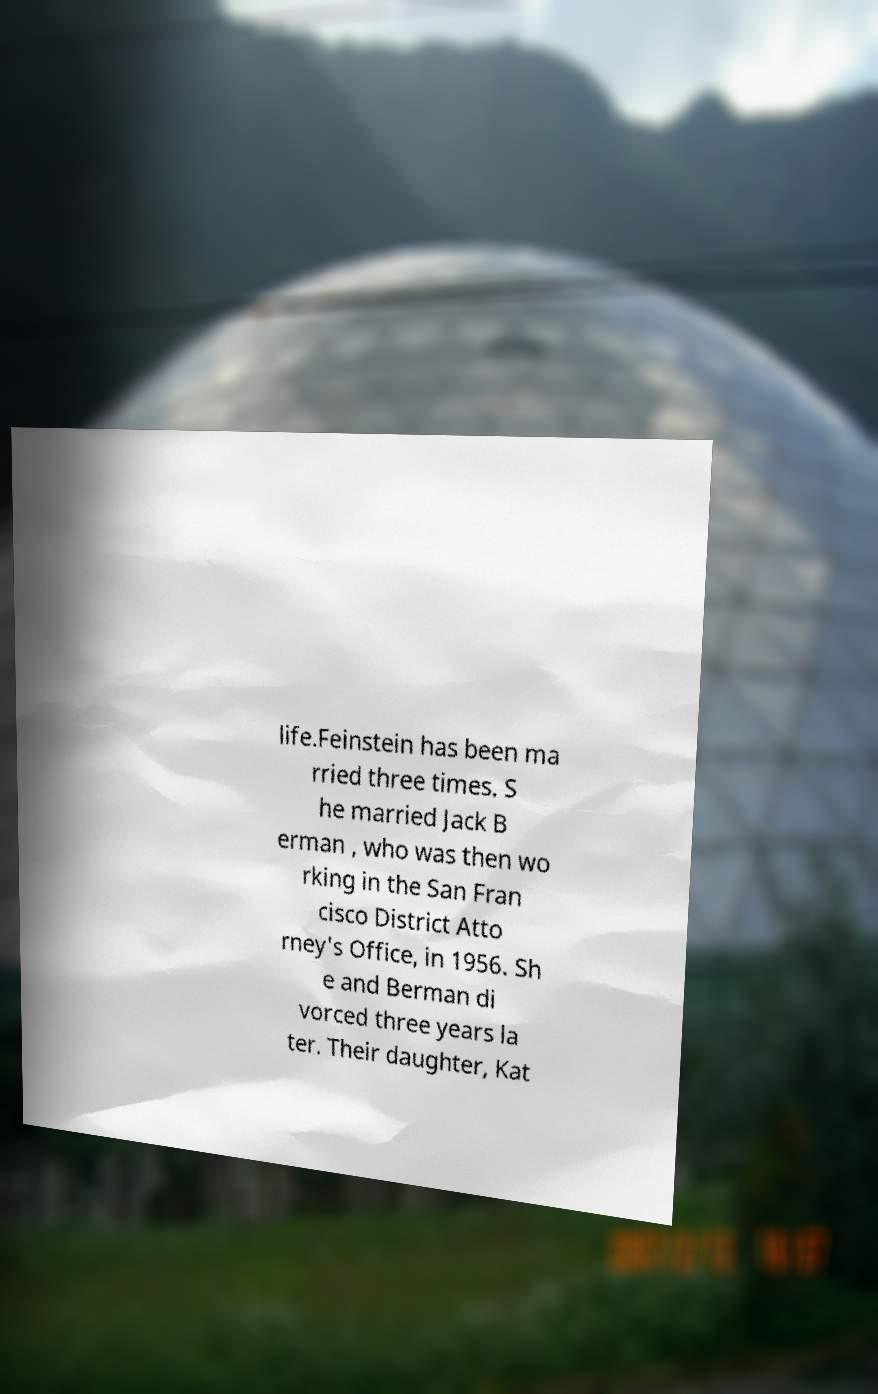Could you assist in decoding the text presented in this image and type it out clearly? life.Feinstein has been ma rried three times. S he married Jack B erman , who was then wo rking in the San Fran cisco District Atto rney's Office, in 1956. Sh e and Berman di vorced three years la ter. Their daughter, Kat 